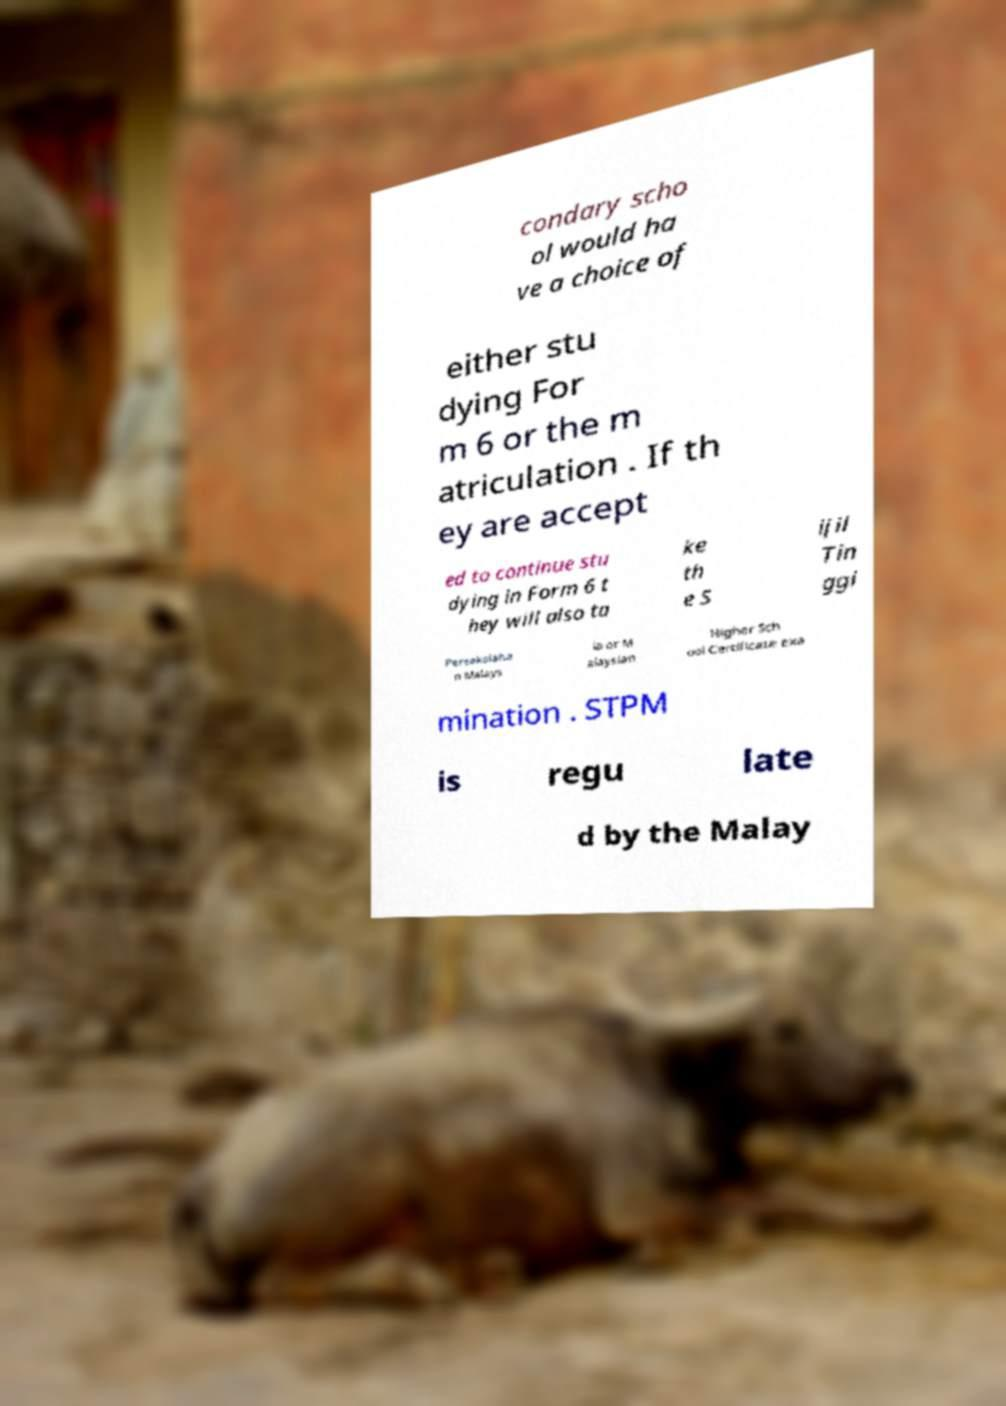There's text embedded in this image that I need extracted. Can you transcribe it verbatim? condary scho ol would ha ve a choice of either stu dying For m 6 or the m atriculation . If th ey are accept ed to continue stu dying in Form 6 t hey will also ta ke th e S ijil Tin ggi Persekolaha n Malays ia or M alaysian Higher Sch ool Certificate exa mination . STPM is regu late d by the Malay 